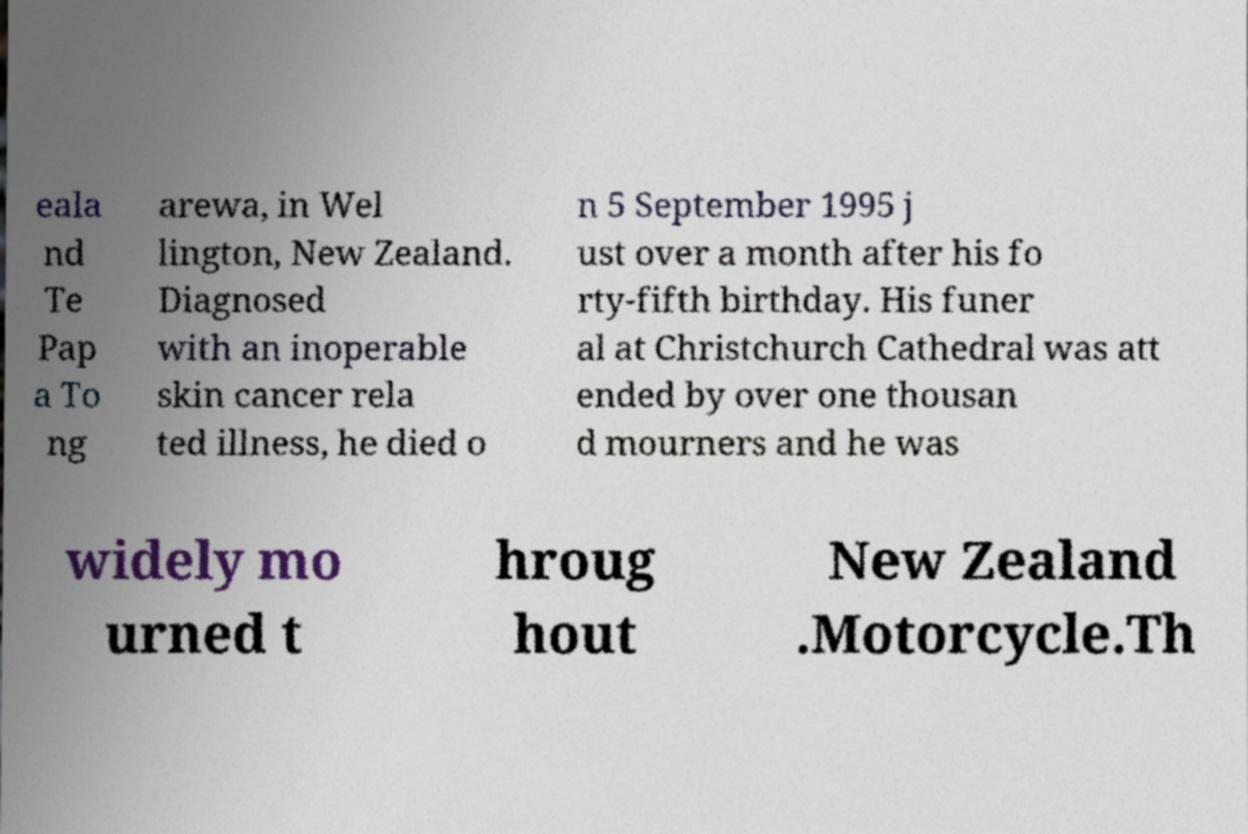What messages or text are displayed in this image? I need them in a readable, typed format. eala nd Te Pap a To ng arewa, in Wel lington, New Zealand. Diagnosed with an inoperable skin cancer rela ted illness, he died o n 5 September 1995 j ust over a month after his fo rty-fifth birthday. His funer al at Christchurch Cathedral was att ended by over one thousan d mourners and he was widely mo urned t hroug hout New Zealand .Motorcycle.Th 